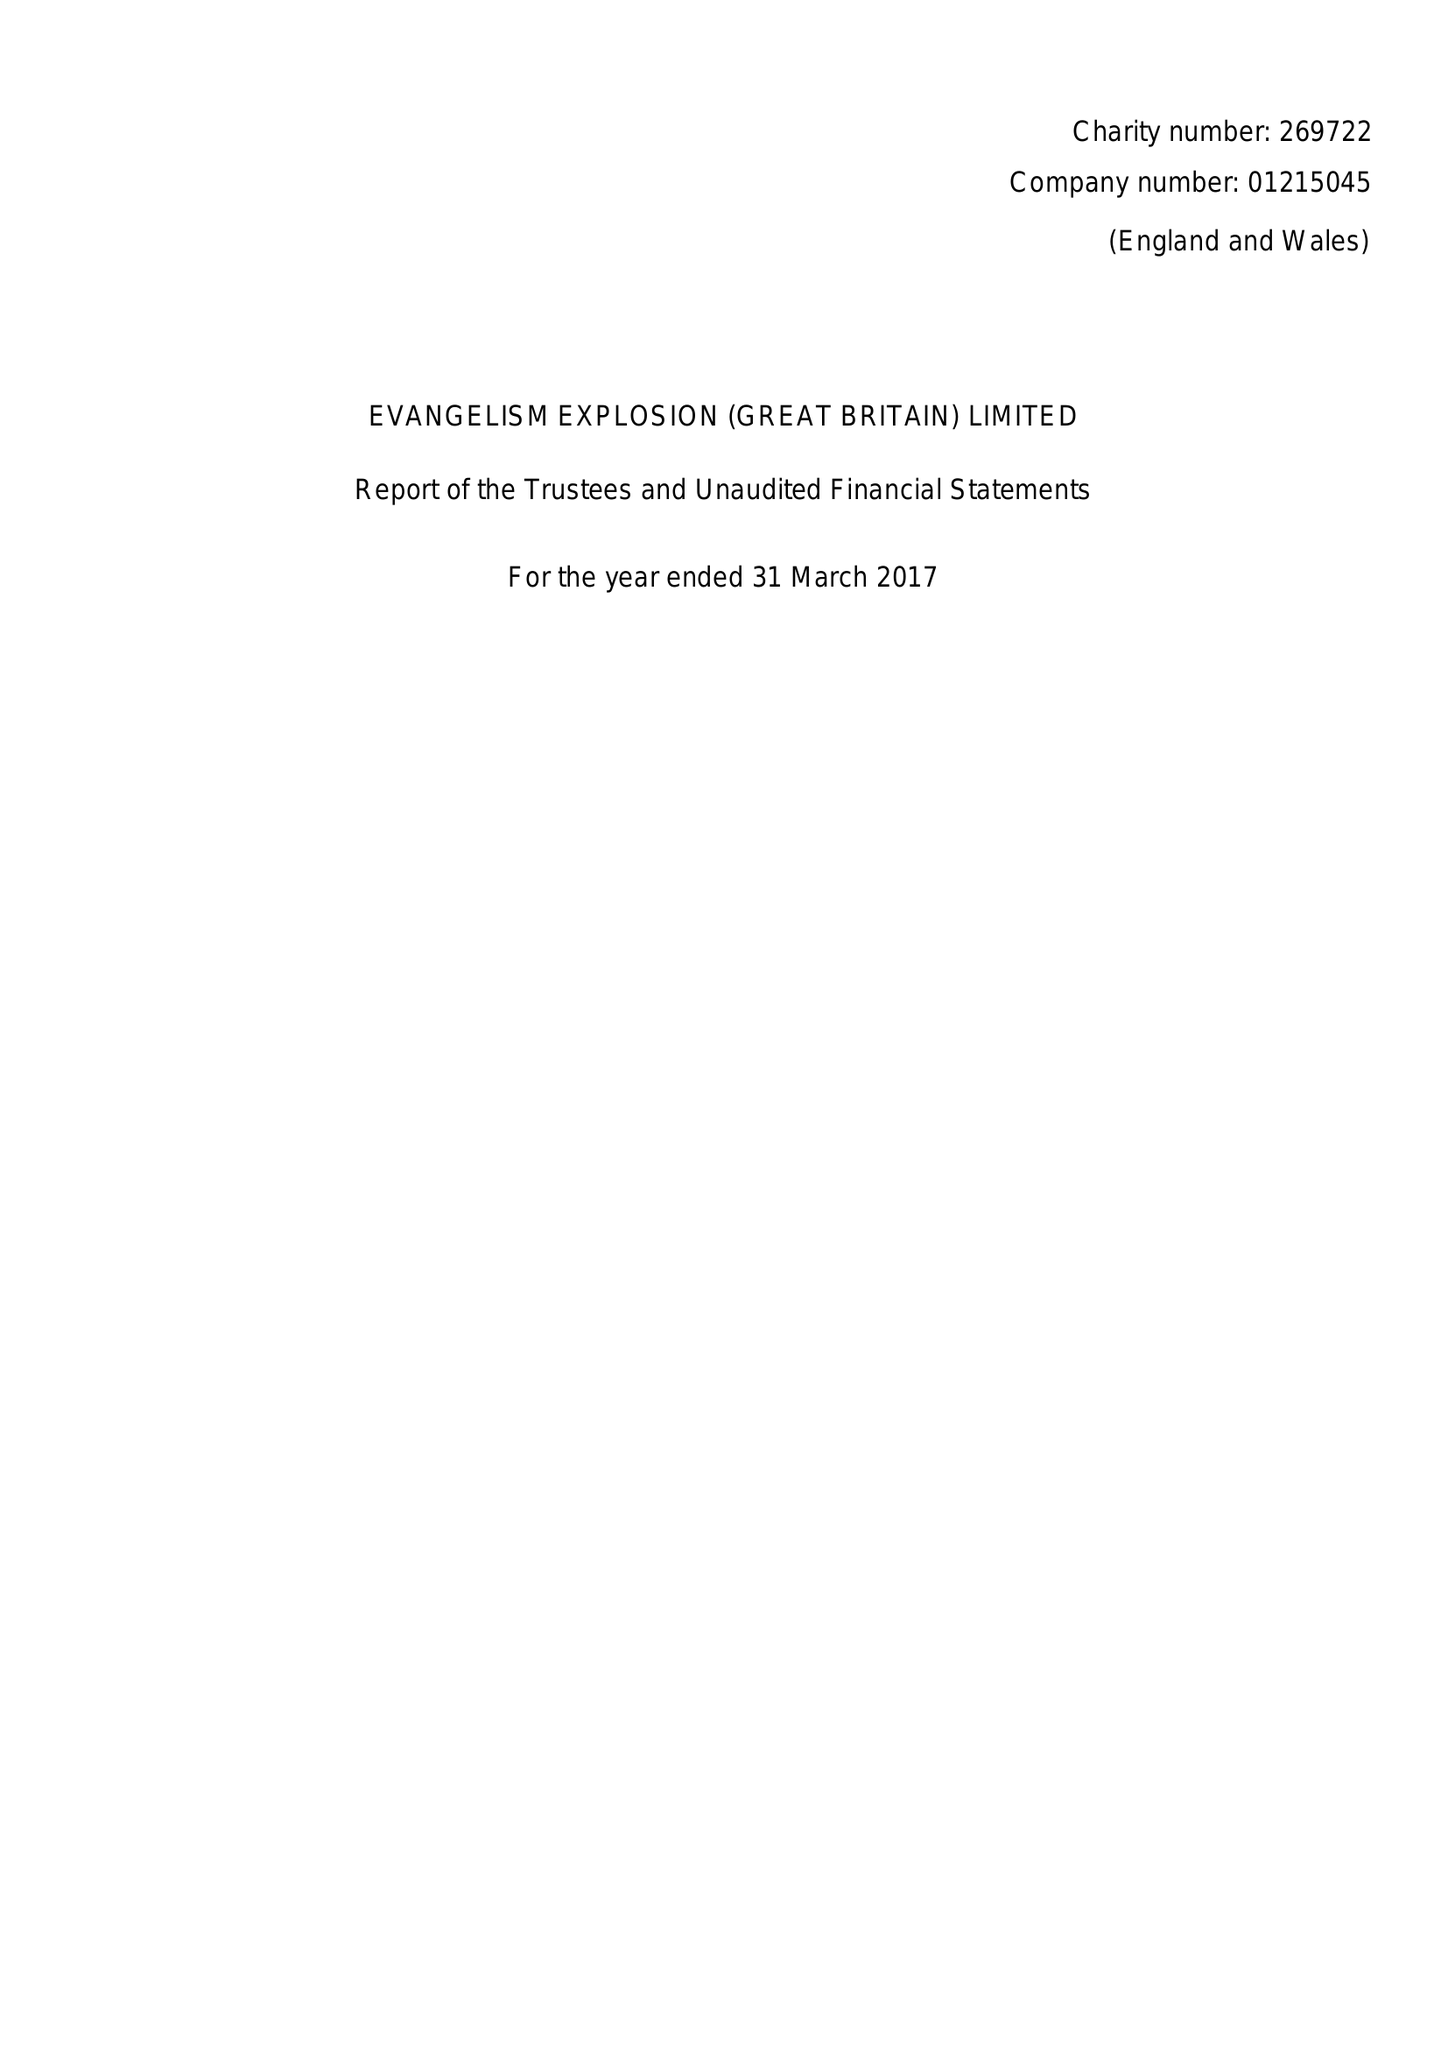What is the value for the spending_annually_in_british_pounds?
Answer the question using a single word or phrase. 30308.00 